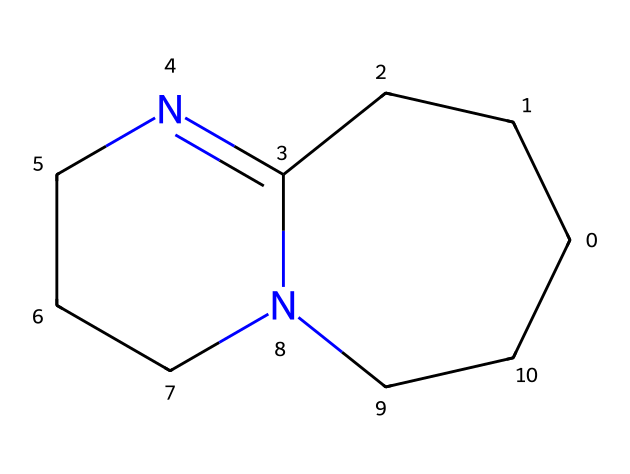What is the molecular formula of DBU? To find the molecular formula, we need to count the number of each type of atom present in the SMILES representation. From the structure C1CCC2=NCCCN2CC1, we can identify 11 carbon atoms, 14 hydrogen atoms, and 2 nitrogen atoms, which gives us a molecular formula of C11H14N2.
Answer: C11H14N2 How many nitrogen atoms are present in this molecule? By analyzing the SMILES representation, we can see there are two 'N' present in the structure. Therefore, the total number of nitrogen atoms is 2.
Answer: 2 What type of chemical compound is DBU classified as? DBU is classified as a superbase due to its strong basicity and ability to deprotonate compounds. This classification can be inferred from its structural characteristics, particularly the presence of the bicyclic system and nitrogen atoms which contribute to its basic properties.
Answer: superbase How many rings are present in DBU? From the SMILES representation, the prefix 'C1CCC2...' indicates a bicyclic structure, which consists of two interconnected rings. Thus, the number of rings present is 2.
Answer: 2 What characteristic of DBU supports its application in medical synthesis? The presence of nitrogen atoms and the overall structure contribute to its high basicity, making it effective for deprotonation in various chemical reactions, particularly in organic synthesis within medical applications. This is a key reason for its utility in synthesis processes.
Answer: high basicity Which element has the highest count in the molecular structure? Upon examining the molecular formula derived earlier, C11H14N2, it is evident that carbon (C) has the highest count with 11 atoms, compared to 14 hydrogens and 2 nitrogens.
Answer: carbon 